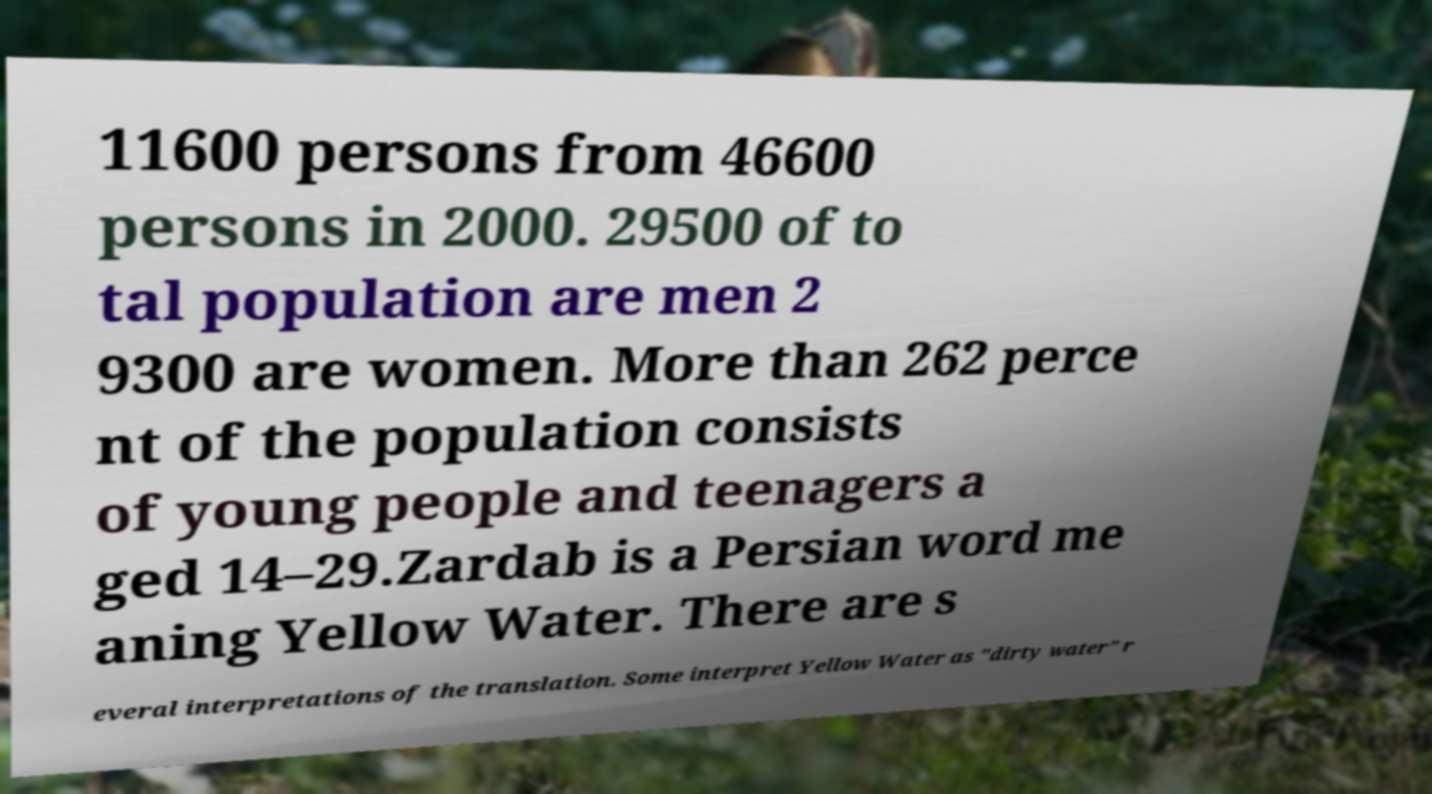Can you accurately transcribe the text from the provided image for me? 11600 persons from 46600 persons in 2000. 29500 of to tal population are men 2 9300 are women. More than 262 perce nt of the population consists of young people and teenagers a ged 14–29.Zardab is a Persian word me aning Yellow Water. There are s everal interpretations of the translation. Some interpret Yellow Water as "dirty water" r 